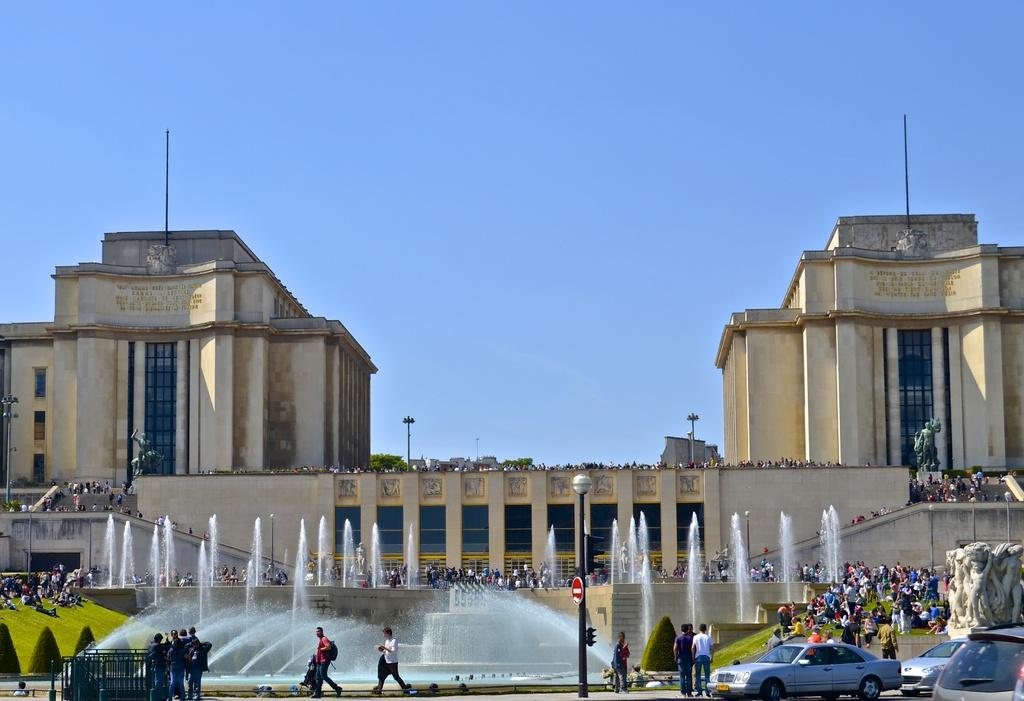What are the people in the image doing? The people in the image are walking on the road. What else can be seen in the image besides people? There are vehicles and light poles in the image. What natural feature is present in the image? There is a waterfall in the image. How would you describe the building in the background? The building in the background is cream-colored. What is the color of the sky in the background? The sky in the background is blue. What type of cable can be seen connecting the waterfall to the building in the image? There is no cable connecting the waterfall to the building in the image. How does the tramp contribute to the overall aesthetic of the image? There is no tramp present in the image, so it does not contribute to the overall aesthetic. 